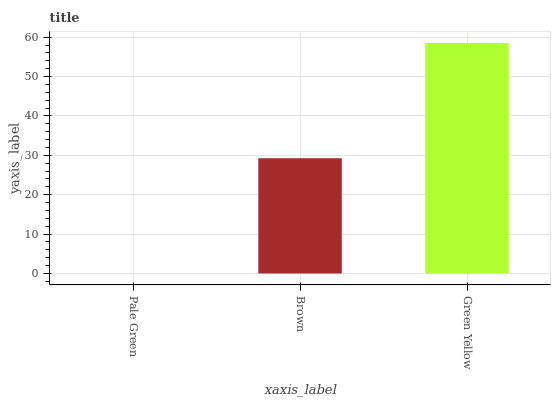Is Brown the minimum?
Answer yes or no. No. Is Brown the maximum?
Answer yes or no. No. Is Brown greater than Pale Green?
Answer yes or no. Yes. Is Pale Green less than Brown?
Answer yes or no. Yes. Is Pale Green greater than Brown?
Answer yes or no. No. Is Brown less than Pale Green?
Answer yes or no. No. Is Brown the high median?
Answer yes or no. Yes. Is Brown the low median?
Answer yes or no. Yes. Is Pale Green the high median?
Answer yes or no. No. Is Pale Green the low median?
Answer yes or no. No. 